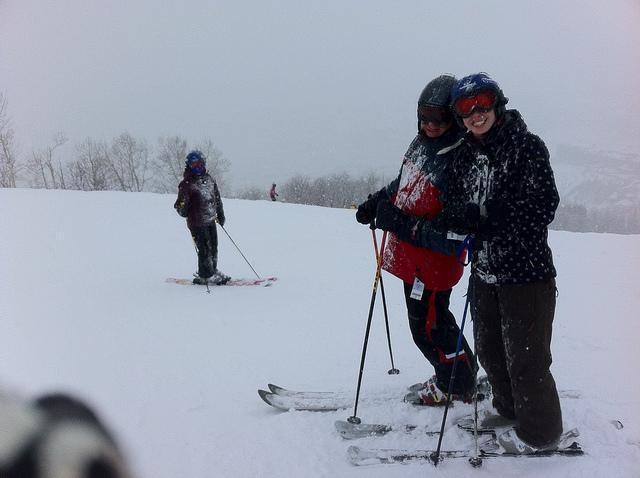How many poles?
Give a very brief answer. 6. How many people are there?
Give a very brief answer. 4. How many skis are shown?
Give a very brief answer. 6. How many ski can be seen?
Give a very brief answer. 2. How many people can you see?
Give a very brief answer. 3. 